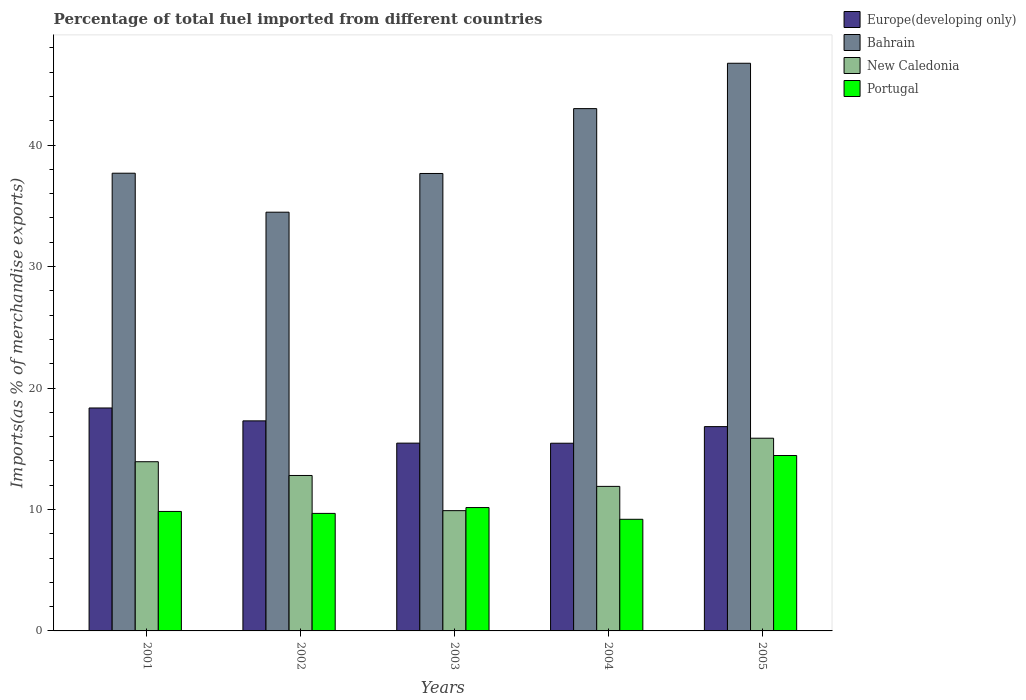How many different coloured bars are there?
Your answer should be compact. 4. Are the number of bars per tick equal to the number of legend labels?
Make the answer very short. Yes. Are the number of bars on each tick of the X-axis equal?
Provide a short and direct response. Yes. How many bars are there on the 4th tick from the left?
Offer a very short reply. 4. How many bars are there on the 1st tick from the right?
Make the answer very short. 4. What is the label of the 1st group of bars from the left?
Keep it short and to the point. 2001. What is the percentage of imports to different countries in Portugal in 2003?
Ensure brevity in your answer.  10.16. Across all years, what is the maximum percentage of imports to different countries in Europe(developing only)?
Your response must be concise. 18.36. Across all years, what is the minimum percentage of imports to different countries in Portugal?
Keep it short and to the point. 9.19. In which year was the percentage of imports to different countries in New Caledonia maximum?
Make the answer very short. 2005. In which year was the percentage of imports to different countries in Europe(developing only) minimum?
Your answer should be compact. 2004. What is the total percentage of imports to different countries in New Caledonia in the graph?
Offer a very short reply. 64.4. What is the difference between the percentage of imports to different countries in Portugal in 2002 and that in 2004?
Your answer should be very brief. 0.48. What is the difference between the percentage of imports to different countries in Portugal in 2005 and the percentage of imports to different countries in Europe(developing only) in 2004?
Give a very brief answer. -1.01. What is the average percentage of imports to different countries in Portugal per year?
Ensure brevity in your answer.  10.66. In the year 2001, what is the difference between the percentage of imports to different countries in Portugal and percentage of imports to different countries in Europe(developing only)?
Your answer should be very brief. -8.52. In how many years, is the percentage of imports to different countries in Europe(developing only) greater than 42 %?
Give a very brief answer. 0. What is the ratio of the percentage of imports to different countries in New Caledonia in 2002 to that in 2004?
Give a very brief answer. 1.08. Is the difference between the percentage of imports to different countries in Portugal in 2002 and 2004 greater than the difference between the percentage of imports to different countries in Europe(developing only) in 2002 and 2004?
Give a very brief answer. No. What is the difference between the highest and the second highest percentage of imports to different countries in Portugal?
Keep it short and to the point. 4.29. What is the difference between the highest and the lowest percentage of imports to different countries in Bahrain?
Your answer should be compact. 12.26. Is the sum of the percentage of imports to different countries in New Caledonia in 2003 and 2004 greater than the maximum percentage of imports to different countries in Bahrain across all years?
Keep it short and to the point. No. What does the 1st bar from the left in 2001 represents?
Offer a terse response. Europe(developing only). Is it the case that in every year, the sum of the percentage of imports to different countries in Bahrain and percentage of imports to different countries in New Caledonia is greater than the percentage of imports to different countries in Portugal?
Provide a succinct answer. Yes. Are all the bars in the graph horizontal?
Provide a succinct answer. No. Are the values on the major ticks of Y-axis written in scientific E-notation?
Provide a short and direct response. No. Does the graph contain grids?
Provide a succinct answer. No. Where does the legend appear in the graph?
Make the answer very short. Top right. How are the legend labels stacked?
Your response must be concise. Vertical. What is the title of the graph?
Make the answer very short. Percentage of total fuel imported from different countries. What is the label or title of the X-axis?
Make the answer very short. Years. What is the label or title of the Y-axis?
Your answer should be very brief. Imports(as % of merchandise exports). What is the Imports(as % of merchandise exports) in Europe(developing only) in 2001?
Ensure brevity in your answer.  18.36. What is the Imports(as % of merchandise exports) of Bahrain in 2001?
Your answer should be very brief. 37.69. What is the Imports(as % of merchandise exports) in New Caledonia in 2001?
Give a very brief answer. 13.93. What is the Imports(as % of merchandise exports) in Portugal in 2001?
Provide a short and direct response. 9.84. What is the Imports(as % of merchandise exports) in Europe(developing only) in 2002?
Your answer should be very brief. 17.3. What is the Imports(as % of merchandise exports) of Bahrain in 2002?
Keep it short and to the point. 34.48. What is the Imports(as % of merchandise exports) in New Caledonia in 2002?
Your answer should be very brief. 12.8. What is the Imports(as % of merchandise exports) in Portugal in 2002?
Offer a very short reply. 9.68. What is the Imports(as % of merchandise exports) in Europe(developing only) in 2003?
Provide a succinct answer. 15.46. What is the Imports(as % of merchandise exports) in Bahrain in 2003?
Ensure brevity in your answer.  37.66. What is the Imports(as % of merchandise exports) of New Caledonia in 2003?
Provide a succinct answer. 9.9. What is the Imports(as % of merchandise exports) of Portugal in 2003?
Offer a very short reply. 10.16. What is the Imports(as % of merchandise exports) in Europe(developing only) in 2004?
Your answer should be very brief. 15.45. What is the Imports(as % of merchandise exports) of Bahrain in 2004?
Provide a succinct answer. 43.01. What is the Imports(as % of merchandise exports) of New Caledonia in 2004?
Your response must be concise. 11.9. What is the Imports(as % of merchandise exports) in Portugal in 2004?
Keep it short and to the point. 9.19. What is the Imports(as % of merchandise exports) of Europe(developing only) in 2005?
Your answer should be compact. 16.82. What is the Imports(as % of merchandise exports) in Bahrain in 2005?
Offer a very short reply. 46.74. What is the Imports(as % of merchandise exports) of New Caledonia in 2005?
Provide a succinct answer. 15.87. What is the Imports(as % of merchandise exports) of Portugal in 2005?
Provide a succinct answer. 14.44. Across all years, what is the maximum Imports(as % of merchandise exports) of Europe(developing only)?
Offer a very short reply. 18.36. Across all years, what is the maximum Imports(as % of merchandise exports) in Bahrain?
Your response must be concise. 46.74. Across all years, what is the maximum Imports(as % of merchandise exports) in New Caledonia?
Your response must be concise. 15.87. Across all years, what is the maximum Imports(as % of merchandise exports) of Portugal?
Provide a short and direct response. 14.44. Across all years, what is the minimum Imports(as % of merchandise exports) in Europe(developing only)?
Provide a short and direct response. 15.45. Across all years, what is the minimum Imports(as % of merchandise exports) of Bahrain?
Make the answer very short. 34.48. Across all years, what is the minimum Imports(as % of merchandise exports) of New Caledonia?
Your answer should be very brief. 9.9. Across all years, what is the minimum Imports(as % of merchandise exports) in Portugal?
Give a very brief answer. 9.19. What is the total Imports(as % of merchandise exports) of Europe(developing only) in the graph?
Provide a short and direct response. 83.39. What is the total Imports(as % of merchandise exports) in Bahrain in the graph?
Ensure brevity in your answer.  199.58. What is the total Imports(as % of merchandise exports) of New Caledonia in the graph?
Make the answer very short. 64.4. What is the total Imports(as % of merchandise exports) of Portugal in the graph?
Provide a succinct answer. 53.31. What is the difference between the Imports(as % of merchandise exports) in Europe(developing only) in 2001 and that in 2002?
Provide a short and direct response. 1.06. What is the difference between the Imports(as % of merchandise exports) in Bahrain in 2001 and that in 2002?
Your answer should be compact. 3.21. What is the difference between the Imports(as % of merchandise exports) of New Caledonia in 2001 and that in 2002?
Your response must be concise. 1.13. What is the difference between the Imports(as % of merchandise exports) of Portugal in 2001 and that in 2002?
Give a very brief answer. 0.16. What is the difference between the Imports(as % of merchandise exports) in Europe(developing only) in 2001 and that in 2003?
Provide a short and direct response. 2.89. What is the difference between the Imports(as % of merchandise exports) of Bahrain in 2001 and that in 2003?
Your answer should be very brief. 0.02. What is the difference between the Imports(as % of merchandise exports) of New Caledonia in 2001 and that in 2003?
Provide a short and direct response. 4.03. What is the difference between the Imports(as % of merchandise exports) of Portugal in 2001 and that in 2003?
Provide a short and direct response. -0.32. What is the difference between the Imports(as % of merchandise exports) of Europe(developing only) in 2001 and that in 2004?
Give a very brief answer. 2.9. What is the difference between the Imports(as % of merchandise exports) of Bahrain in 2001 and that in 2004?
Your answer should be compact. -5.32. What is the difference between the Imports(as % of merchandise exports) of New Caledonia in 2001 and that in 2004?
Give a very brief answer. 2.03. What is the difference between the Imports(as % of merchandise exports) of Portugal in 2001 and that in 2004?
Offer a terse response. 0.65. What is the difference between the Imports(as % of merchandise exports) of Europe(developing only) in 2001 and that in 2005?
Make the answer very short. 1.53. What is the difference between the Imports(as % of merchandise exports) in Bahrain in 2001 and that in 2005?
Your response must be concise. -9.05. What is the difference between the Imports(as % of merchandise exports) of New Caledonia in 2001 and that in 2005?
Provide a short and direct response. -1.94. What is the difference between the Imports(as % of merchandise exports) in Portugal in 2001 and that in 2005?
Your answer should be very brief. -4.6. What is the difference between the Imports(as % of merchandise exports) in Europe(developing only) in 2002 and that in 2003?
Your answer should be very brief. 1.83. What is the difference between the Imports(as % of merchandise exports) in Bahrain in 2002 and that in 2003?
Keep it short and to the point. -3.19. What is the difference between the Imports(as % of merchandise exports) of New Caledonia in 2002 and that in 2003?
Your answer should be very brief. 2.9. What is the difference between the Imports(as % of merchandise exports) in Portugal in 2002 and that in 2003?
Your answer should be compact. -0.48. What is the difference between the Imports(as % of merchandise exports) of Europe(developing only) in 2002 and that in 2004?
Keep it short and to the point. 1.84. What is the difference between the Imports(as % of merchandise exports) in Bahrain in 2002 and that in 2004?
Give a very brief answer. -8.53. What is the difference between the Imports(as % of merchandise exports) of New Caledonia in 2002 and that in 2004?
Your answer should be very brief. 0.9. What is the difference between the Imports(as % of merchandise exports) in Portugal in 2002 and that in 2004?
Keep it short and to the point. 0.48. What is the difference between the Imports(as % of merchandise exports) of Europe(developing only) in 2002 and that in 2005?
Your answer should be very brief. 0.47. What is the difference between the Imports(as % of merchandise exports) in Bahrain in 2002 and that in 2005?
Make the answer very short. -12.26. What is the difference between the Imports(as % of merchandise exports) in New Caledonia in 2002 and that in 2005?
Offer a very short reply. -3.07. What is the difference between the Imports(as % of merchandise exports) of Portugal in 2002 and that in 2005?
Provide a short and direct response. -4.77. What is the difference between the Imports(as % of merchandise exports) of Europe(developing only) in 2003 and that in 2004?
Your answer should be very brief. 0.01. What is the difference between the Imports(as % of merchandise exports) in Bahrain in 2003 and that in 2004?
Your answer should be compact. -5.34. What is the difference between the Imports(as % of merchandise exports) of New Caledonia in 2003 and that in 2004?
Keep it short and to the point. -2. What is the difference between the Imports(as % of merchandise exports) in Portugal in 2003 and that in 2004?
Give a very brief answer. 0.97. What is the difference between the Imports(as % of merchandise exports) of Europe(developing only) in 2003 and that in 2005?
Your answer should be very brief. -1.36. What is the difference between the Imports(as % of merchandise exports) in Bahrain in 2003 and that in 2005?
Offer a terse response. -9.08. What is the difference between the Imports(as % of merchandise exports) of New Caledonia in 2003 and that in 2005?
Offer a terse response. -5.96. What is the difference between the Imports(as % of merchandise exports) of Portugal in 2003 and that in 2005?
Provide a short and direct response. -4.29. What is the difference between the Imports(as % of merchandise exports) in Europe(developing only) in 2004 and that in 2005?
Your answer should be compact. -1.37. What is the difference between the Imports(as % of merchandise exports) in Bahrain in 2004 and that in 2005?
Keep it short and to the point. -3.73. What is the difference between the Imports(as % of merchandise exports) of New Caledonia in 2004 and that in 2005?
Your response must be concise. -3.97. What is the difference between the Imports(as % of merchandise exports) in Portugal in 2004 and that in 2005?
Provide a succinct answer. -5.25. What is the difference between the Imports(as % of merchandise exports) of Europe(developing only) in 2001 and the Imports(as % of merchandise exports) of Bahrain in 2002?
Your answer should be compact. -16.12. What is the difference between the Imports(as % of merchandise exports) in Europe(developing only) in 2001 and the Imports(as % of merchandise exports) in New Caledonia in 2002?
Your answer should be very brief. 5.56. What is the difference between the Imports(as % of merchandise exports) in Europe(developing only) in 2001 and the Imports(as % of merchandise exports) in Portugal in 2002?
Provide a short and direct response. 8.68. What is the difference between the Imports(as % of merchandise exports) in Bahrain in 2001 and the Imports(as % of merchandise exports) in New Caledonia in 2002?
Ensure brevity in your answer.  24.89. What is the difference between the Imports(as % of merchandise exports) in Bahrain in 2001 and the Imports(as % of merchandise exports) in Portugal in 2002?
Make the answer very short. 28.01. What is the difference between the Imports(as % of merchandise exports) of New Caledonia in 2001 and the Imports(as % of merchandise exports) of Portugal in 2002?
Offer a very short reply. 4.25. What is the difference between the Imports(as % of merchandise exports) in Europe(developing only) in 2001 and the Imports(as % of merchandise exports) in Bahrain in 2003?
Ensure brevity in your answer.  -19.31. What is the difference between the Imports(as % of merchandise exports) of Europe(developing only) in 2001 and the Imports(as % of merchandise exports) of New Caledonia in 2003?
Your answer should be compact. 8.45. What is the difference between the Imports(as % of merchandise exports) in Europe(developing only) in 2001 and the Imports(as % of merchandise exports) in Portugal in 2003?
Your answer should be very brief. 8.2. What is the difference between the Imports(as % of merchandise exports) of Bahrain in 2001 and the Imports(as % of merchandise exports) of New Caledonia in 2003?
Provide a short and direct response. 27.78. What is the difference between the Imports(as % of merchandise exports) of Bahrain in 2001 and the Imports(as % of merchandise exports) of Portugal in 2003?
Offer a very short reply. 27.53. What is the difference between the Imports(as % of merchandise exports) in New Caledonia in 2001 and the Imports(as % of merchandise exports) in Portugal in 2003?
Make the answer very short. 3.77. What is the difference between the Imports(as % of merchandise exports) in Europe(developing only) in 2001 and the Imports(as % of merchandise exports) in Bahrain in 2004?
Give a very brief answer. -24.65. What is the difference between the Imports(as % of merchandise exports) in Europe(developing only) in 2001 and the Imports(as % of merchandise exports) in New Caledonia in 2004?
Provide a short and direct response. 6.46. What is the difference between the Imports(as % of merchandise exports) in Europe(developing only) in 2001 and the Imports(as % of merchandise exports) in Portugal in 2004?
Provide a short and direct response. 9.16. What is the difference between the Imports(as % of merchandise exports) in Bahrain in 2001 and the Imports(as % of merchandise exports) in New Caledonia in 2004?
Keep it short and to the point. 25.79. What is the difference between the Imports(as % of merchandise exports) in Bahrain in 2001 and the Imports(as % of merchandise exports) in Portugal in 2004?
Keep it short and to the point. 28.49. What is the difference between the Imports(as % of merchandise exports) of New Caledonia in 2001 and the Imports(as % of merchandise exports) of Portugal in 2004?
Make the answer very short. 4.74. What is the difference between the Imports(as % of merchandise exports) in Europe(developing only) in 2001 and the Imports(as % of merchandise exports) in Bahrain in 2005?
Your response must be concise. -28.38. What is the difference between the Imports(as % of merchandise exports) in Europe(developing only) in 2001 and the Imports(as % of merchandise exports) in New Caledonia in 2005?
Keep it short and to the point. 2.49. What is the difference between the Imports(as % of merchandise exports) of Europe(developing only) in 2001 and the Imports(as % of merchandise exports) of Portugal in 2005?
Your answer should be very brief. 3.91. What is the difference between the Imports(as % of merchandise exports) in Bahrain in 2001 and the Imports(as % of merchandise exports) in New Caledonia in 2005?
Offer a very short reply. 21.82. What is the difference between the Imports(as % of merchandise exports) in Bahrain in 2001 and the Imports(as % of merchandise exports) in Portugal in 2005?
Offer a terse response. 23.24. What is the difference between the Imports(as % of merchandise exports) of New Caledonia in 2001 and the Imports(as % of merchandise exports) of Portugal in 2005?
Give a very brief answer. -0.51. What is the difference between the Imports(as % of merchandise exports) in Europe(developing only) in 2002 and the Imports(as % of merchandise exports) in Bahrain in 2003?
Make the answer very short. -20.37. What is the difference between the Imports(as % of merchandise exports) in Europe(developing only) in 2002 and the Imports(as % of merchandise exports) in New Caledonia in 2003?
Your answer should be very brief. 7.39. What is the difference between the Imports(as % of merchandise exports) in Europe(developing only) in 2002 and the Imports(as % of merchandise exports) in Portugal in 2003?
Provide a succinct answer. 7.14. What is the difference between the Imports(as % of merchandise exports) of Bahrain in 2002 and the Imports(as % of merchandise exports) of New Caledonia in 2003?
Your response must be concise. 24.57. What is the difference between the Imports(as % of merchandise exports) of Bahrain in 2002 and the Imports(as % of merchandise exports) of Portugal in 2003?
Offer a very short reply. 24.32. What is the difference between the Imports(as % of merchandise exports) of New Caledonia in 2002 and the Imports(as % of merchandise exports) of Portugal in 2003?
Make the answer very short. 2.64. What is the difference between the Imports(as % of merchandise exports) of Europe(developing only) in 2002 and the Imports(as % of merchandise exports) of Bahrain in 2004?
Provide a succinct answer. -25.71. What is the difference between the Imports(as % of merchandise exports) in Europe(developing only) in 2002 and the Imports(as % of merchandise exports) in New Caledonia in 2004?
Give a very brief answer. 5.39. What is the difference between the Imports(as % of merchandise exports) in Europe(developing only) in 2002 and the Imports(as % of merchandise exports) in Portugal in 2004?
Offer a very short reply. 8.1. What is the difference between the Imports(as % of merchandise exports) in Bahrain in 2002 and the Imports(as % of merchandise exports) in New Caledonia in 2004?
Your answer should be compact. 22.58. What is the difference between the Imports(as % of merchandise exports) of Bahrain in 2002 and the Imports(as % of merchandise exports) of Portugal in 2004?
Make the answer very short. 25.29. What is the difference between the Imports(as % of merchandise exports) of New Caledonia in 2002 and the Imports(as % of merchandise exports) of Portugal in 2004?
Your response must be concise. 3.61. What is the difference between the Imports(as % of merchandise exports) of Europe(developing only) in 2002 and the Imports(as % of merchandise exports) of Bahrain in 2005?
Make the answer very short. -29.45. What is the difference between the Imports(as % of merchandise exports) in Europe(developing only) in 2002 and the Imports(as % of merchandise exports) in New Caledonia in 2005?
Make the answer very short. 1.43. What is the difference between the Imports(as % of merchandise exports) in Europe(developing only) in 2002 and the Imports(as % of merchandise exports) in Portugal in 2005?
Your response must be concise. 2.85. What is the difference between the Imports(as % of merchandise exports) of Bahrain in 2002 and the Imports(as % of merchandise exports) of New Caledonia in 2005?
Make the answer very short. 18.61. What is the difference between the Imports(as % of merchandise exports) in Bahrain in 2002 and the Imports(as % of merchandise exports) in Portugal in 2005?
Offer a very short reply. 20.03. What is the difference between the Imports(as % of merchandise exports) of New Caledonia in 2002 and the Imports(as % of merchandise exports) of Portugal in 2005?
Offer a very short reply. -1.64. What is the difference between the Imports(as % of merchandise exports) in Europe(developing only) in 2003 and the Imports(as % of merchandise exports) in Bahrain in 2004?
Offer a very short reply. -27.54. What is the difference between the Imports(as % of merchandise exports) of Europe(developing only) in 2003 and the Imports(as % of merchandise exports) of New Caledonia in 2004?
Make the answer very short. 3.56. What is the difference between the Imports(as % of merchandise exports) in Europe(developing only) in 2003 and the Imports(as % of merchandise exports) in Portugal in 2004?
Your answer should be compact. 6.27. What is the difference between the Imports(as % of merchandise exports) of Bahrain in 2003 and the Imports(as % of merchandise exports) of New Caledonia in 2004?
Provide a succinct answer. 25.76. What is the difference between the Imports(as % of merchandise exports) in Bahrain in 2003 and the Imports(as % of merchandise exports) in Portugal in 2004?
Offer a terse response. 28.47. What is the difference between the Imports(as % of merchandise exports) in New Caledonia in 2003 and the Imports(as % of merchandise exports) in Portugal in 2004?
Provide a short and direct response. 0.71. What is the difference between the Imports(as % of merchandise exports) of Europe(developing only) in 2003 and the Imports(as % of merchandise exports) of Bahrain in 2005?
Make the answer very short. -31.28. What is the difference between the Imports(as % of merchandise exports) in Europe(developing only) in 2003 and the Imports(as % of merchandise exports) in New Caledonia in 2005?
Your answer should be compact. -0.4. What is the difference between the Imports(as % of merchandise exports) in Europe(developing only) in 2003 and the Imports(as % of merchandise exports) in Portugal in 2005?
Provide a short and direct response. 1.02. What is the difference between the Imports(as % of merchandise exports) in Bahrain in 2003 and the Imports(as % of merchandise exports) in New Caledonia in 2005?
Offer a terse response. 21.8. What is the difference between the Imports(as % of merchandise exports) in Bahrain in 2003 and the Imports(as % of merchandise exports) in Portugal in 2005?
Keep it short and to the point. 23.22. What is the difference between the Imports(as % of merchandise exports) in New Caledonia in 2003 and the Imports(as % of merchandise exports) in Portugal in 2005?
Offer a very short reply. -4.54. What is the difference between the Imports(as % of merchandise exports) of Europe(developing only) in 2004 and the Imports(as % of merchandise exports) of Bahrain in 2005?
Give a very brief answer. -31.29. What is the difference between the Imports(as % of merchandise exports) in Europe(developing only) in 2004 and the Imports(as % of merchandise exports) in New Caledonia in 2005?
Ensure brevity in your answer.  -0.41. What is the difference between the Imports(as % of merchandise exports) of Europe(developing only) in 2004 and the Imports(as % of merchandise exports) of Portugal in 2005?
Keep it short and to the point. 1.01. What is the difference between the Imports(as % of merchandise exports) in Bahrain in 2004 and the Imports(as % of merchandise exports) in New Caledonia in 2005?
Make the answer very short. 27.14. What is the difference between the Imports(as % of merchandise exports) of Bahrain in 2004 and the Imports(as % of merchandise exports) of Portugal in 2005?
Offer a very short reply. 28.56. What is the difference between the Imports(as % of merchandise exports) in New Caledonia in 2004 and the Imports(as % of merchandise exports) in Portugal in 2005?
Keep it short and to the point. -2.54. What is the average Imports(as % of merchandise exports) in Europe(developing only) per year?
Offer a terse response. 16.68. What is the average Imports(as % of merchandise exports) of Bahrain per year?
Give a very brief answer. 39.92. What is the average Imports(as % of merchandise exports) of New Caledonia per year?
Offer a very short reply. 12.88. What is the average Imports(as % of merchandise exports) in Portugal per year?
Ensure brevity in your answer.  10.66. In the year 2001, what is the difference between the Imports(as % of merchandise exports) of Europe(developing only) and Imports(as % of merchandise exports) of Bahrain?
Keep it short and to the point. -19.33. In the year 2001, what is the difference between the Imports(as % of merchandise exports) of Europe(developing only) and Imports(as % of merchandise exports) of New Caledonia?
Your answer should be compact. 4.43. In the year 2001, what is the difference between the Imports(as % of merchandise exports) in Europe(developing only) and Imports(as % of merchandise exports) in Portugal?
Offer a terse response. 8.52. In the year 2001, what is the difference between the Imports(as % of merchandise exports) of Bahrain and Imports(as % of merchandise exports) of New Caledonia?
Your answer should be compact. 23.76. In the year 2001, what is the difference between the Imports(as % of merchandise exports) in Bahrain and Imports(as % of merchandise exports) in Portugal?
Keep it short and to the point. 27.85. In the year 2001, what is the difference between the Imports(as % of merchandise exports) in New Caledonia and Imports(as % of merchandise exports) in Portugal?
Your response must be concise. 4.09. In the year 2002, what is the difference between the Imports(as % of merchandise exports) of Europe(developing only) and Imports(as % of merchandise exports) of Bahrain?
Your response must be concise. -17.18. In the year 2002, what is the difference between the Imports(as % of merchandise exports) in Europe(developing only) and Imports(as % of merchandise exports) in New Caledonia?
Make the answer very short. 4.5. In the year 2002, what is the difference between the Imports(as % of merchandise exports) of Europe(developing only) and Imports(as % of merchandise exports) of Portugal?
Provide a short and direct response. 7.62. In the year 2002, what is the difference between the Imports(as % of merchandise exports) in Bahrain and Imports(as % of merchandise exports) in New Caledonia?
Give a very brief answer. 21.68. In the year 2002, what is the difference between the Imports(as % of merchandise exports) of Bahrain and Imports(as % of merchandise exports) of Portugal?
Your answer should be very brief. 24.8. In the year 2002, what is the difference between the Imports(as % of merchandise exports) in New Caledonia and Imports(as % of merchandise exports) in Portugal?
Offer a very short reply. 3.12. In the year 2003, what is the difference between the Imports(as % of merchandise exports) of Europe(developing only) and Imports(as % of merchandise exports) of Bahrain?
Provide a short and direct response. -22.2. In the year 2003, what is the difference between the Imports(as % of merchandise exports) of Europe(developing only) and Imports(as % of merchandise exports) of New Caledonia?
Your answer should be very brief. 5.56. In the year 2003, what is the difference between the Imports(as % of merchandise exports) of Europe(developing only) and Imports(as % of merchandise exports) of Portugal?
Give a very brief answer. 5.3. In the year 2003, what is the difference between the Imports(as % of merchandise exports) in Bahrain and Imports(as % of merchandise exports) in New Caledonia?
Give a very brief answer. 27.76. In the year 2003, what is the difference between the Imports(as % of merchandise exports) in Bahrain and Imports(as % of merchandise exports) in Portugal?
Provide a short and direct response. 27.51. In the year 2003, what is the difference between the Imports(as % of merchandise exports) in New Caledonia and Imports(as % of merchandise exports) in Portugal?
Provide a succinct answer. -0.25. In the year 2004, what is the difference between the Imports(as % of merchandise exports) of Europe(developing only) and Imports(as % of merchandise exports) of Bahrain?
Provide a succinct answer. -27.55. In the year 2004, what is the difference between the Imports(as % of merchandise exports) in Europe(developing only) and Imports(as % of merchandise exports) in New Caledonia?
Make the answer very short. 3.55. In the year 2004, what is the difference between the Imports(as % of merchandise exports) in Europe(developing only) and Imports(as % of merchandise exports) in Portugal?
Give a very brief answer. 6.26. In the year 2004, what is the difference between the Imports(as % of merchandise exports) of Bahrain and Imports(as % of merchandise exports) of New Caledonia?
Give a very brief answer. 31.1. In the year 2004, what is the difference between the Imports(as % of merchandise exports) of Bahrain and Imports(as % of merchandise exports) of Portugal?
Give a very brief answer. 33.81. In the year 2004, what is the difference between the Imports(as % of merchandise exports) in New Caledonia and Imports(as % of merchandise exports) in Portugal?
Offer a terse response. 2.71. In the year 2005, what is the difference between the Imports(as % of merchandise exports) of Europe(developing only) and Imports(as % of merchandise exports) of Bahrain?
Keep it short and to the point. -29.92. In the year 2005, what is the difference between the Imports(as % of merchandise exports) in Europe(developing only) and Imports(as % of merchandise exports) in New Caledonia?
Offer a terse response. 0.95. In the year 2005, what is the difference between the Imports(as % of merchandise exports) in Europe(developing only) and Imports(as % of merchandise exports) in Portugal?
Provide a succinct answer. 2.38. In the year 2005, what is the difference between the Imports(as % of merchandise exports) in Bahrain and Imports(as % of merchandise exports) in New Caledonia?
Keep it short and to the point. 30.87. In the year 2005, what is the difference between the Imports(as % of merchandise exports) of Bahrain and Imports(as % of merchandise exports) of Portugal?
Your response must be concise. 32.3. In the year 2005, what is the difference between the Imports(as % of merchandise exports) of New Caledonia and Imports(as % of merchandise exports) of Portugal?
Your answer should be compact. 1.42. What is the ratio of the Imports(as % of merchandise exports) in Europe(developing only) in 2001 to that in 2002?
Provide a succinct answer. 1.06. What is the ratio of the Imports(as % of merchandise exports) in Bahrain in 2001 to that in 2002?
Ensure brevity in your answer.  1.09. What is the ratio of the Imports(as % of merchandise exports) of New Caledonia in 2001 to that in 2002?
Your answer should be compact. 1.09. What is the ratio of the Imports(as % of merchandise exports) of Portugal in 2001 to that in 2002?
Offer a terse response. 1.02. What is the ratio of the Imports(as % of merchandise exports) in Europe(developing only) in 2001 to that in 2003?
Offer a terse response. 1.19. What is the ratio of the Imports(as % of merchandise exports) of Bahrain in 2001 to that in 2003?
Give a very brief answer. 1. What is the ratio of the Imports(as % of merchandise exports) of New Caledonia in 2001 to that in 2003?
Your response must be concise. 1.41. What is the ratio of the Imports(as % of merchandise exports) in Portugal in 2001 to that in 2003?
Offer a terse response. 0.97. What is the ratio of the Imports(as % of merchandise exports) in Europe(developing only) in 2001 to that in 2004?
Your answer should be compact. 1.19. What is the ratio of the Imports(as % of merchandise exports) of Bahrain in 2001 to that in 2004?
Keep it short and to the point. 0.88. What is the ratio of the Imports(as % of merchandise exports) of New Caledonia in 2001 to that in 2004?
Your answer should be very brief. 1.17. What is the ratio of the Imports(as % of merchandise exports) of Portugal in 2001 to that in 2004?
Your answer should be very brief. 1.07. What is the ratio of the Imports(as % of merchandise exports) in Europe(developing only) in 2001 to that in 2005?
Your response must be concise. 1.09. What is the ratio of the Imports(as % of merchandise exports) of Bahrain in 2001 to that in 2005?
Make the answer very short. 0.81. What is the ratio of the Imports(as % of merchandise exports) of New Caledonia in 2001 to that in 2005?
Provide a succinct answer. 0.88. What is the ratio of the Imports(as % of merchandise exports) in Portugal in 2001 to that in 2005?
Your answer should be compact. 0.68. What is the ratio of the Imports(as % of merchandise exports) in Europe(developing only) in 2002 to that in 2003?
Give a very brief answer. 1.12. What is the ratio of the Imports(as % of merchandise exports) in Bahrain in 2002 to that in 2003?
Keep it short and to the point. 0.92. What is the ratio of the Imports(as % of merchandise exports) in New Caledonia in 2002 to that in 2003?
Offer a terse response. 1.29. What is the ratio of the Imports(as % of merchandise exports) of Portugal in 2002 to that in 2003?
Provide a short and direct response. 0.95. What is the ratio of the Imports(as % of merchandise exports) of Europe(developing only) in 2002 to that in 2004?
Offer a very short reply. 1.12. What is the ratio of the Imports(as % of merchandise exports) in Bahrain in 2002 to that in 2004?
Make the answer very short. 0.8. What is the ratio of the Imports(as % of merchandise exports) in New Caledonia in 2002 to that in 2004?
Make the answer very short. 1.08. What is the ratio of the Imports(as % of merchandise exports) in Portugal in 2002 to that in 2004?
Ensure brevity in your answer.  1.05. What is the ratio of the Imports(as % of merchandise exports) of Europe(developing only) in 2002 to that in 2005?
Offer a terse response. 1.03. What is the ratio of the Imports(as % of merchandise exports) of Bahrain in 2002 to that in 2005?
Provide a succinct answer. 0.74. What is the ratio of the Imports(as % of merchandise exports) in New Caledonia in 2002 to that in 2005?
Keep it short and to the point. 0.81. What is the ratio of the Imports(as % of merchandise exports) in Portugal in 2002 to that in 2005?
Make the answer very short. 0.67. What is the ratio of the Imports(as % of merchandise exports) of Bahrain in 2003 to that in 2004?
Provide a short and direct response. 0.88. What is the ratio of the Imports(as % of merchandise exports) of New Caledonia in 2003 to that in 2004?
Your response must be concise. 0.83. What is the ratio of the Imports(as % of merchandise exports) of Portugal in 2003 to that in 2004?
Offer a terse response. 1.1. What is the ratio of the Imports(as % of merchandise exports) of Europe(developing only) in 2003 to that in 2005?
Your answer should be compact. 0.92. What is the ratio of the Imports(as % of merchandise exports) of Bahrain in 2003 to that in 2005?
Offer a terse response. 0.81. What is the ratio of the Imports(as % of merchandise exports) of New Caledonia in 2003 to that in 2005?
Your answer should be very brief. 0.62. What is the ratio of the Imports(as % of merchandise exports) of Portugal in 2003 to that in 2005?
Keep it short and to the point. 0.7. What is the ratio of the Imports(as % of merchandise exports) of Europe(developing only) in 2004 to that in 2005?
Give a very brief answer. 0.92. What is the ratio of the Imports(as % of merchandise exports) of Bahrain in 2004 to that in 2005?
Your answer should be very brief. 0.92. What is the ratio of the Imports(as % of merchandise exports) of New Caledonia in 2004 to that in 2005?
Offer a terse response. 0.75. What is the ratio of the Imports(as % of merchandise exports) of Portugal in 2004 to that in 2005?
Offer a terse response. 0.64. What is the difference between the highest and the second highest Imports(as % of merchandise exports) in Europe(developing only)?
Give a very brief answer. 1.06. What is the difference between the highest and the second highest Imports(as % of merchandise exports) of Bahrain?
Offer a terse response. 3.73. What is the difference between the highest and the second highest Imports(as % of merchandise exports) of New Caledonia?
Provide a short and direct response. 1.94. What is the difference between the highest and the second highest Imports(as % of merchandise exports) of Portugal?
Ensure brevity in your answer.  4.29. What is the difference between the highest and the lowest Imports(as % of merchandise exports) of Europe(developing only)?
Ensure brevity in your answer.  2.9. What is the difference between the highest and the lowest Imports(as % of merchandise exports) of Bahrain?
Provide a succinct answer. 12.26. What is the difference between the highest and the lowest Imports(as % of merchandise exports) of New Caledonia?
Your response must be concise. 5.96. What is the difference between the highest and the lowest Imports(as % of merchandise exports) in Portugal?
Provide a short and direct response. 5.25. 